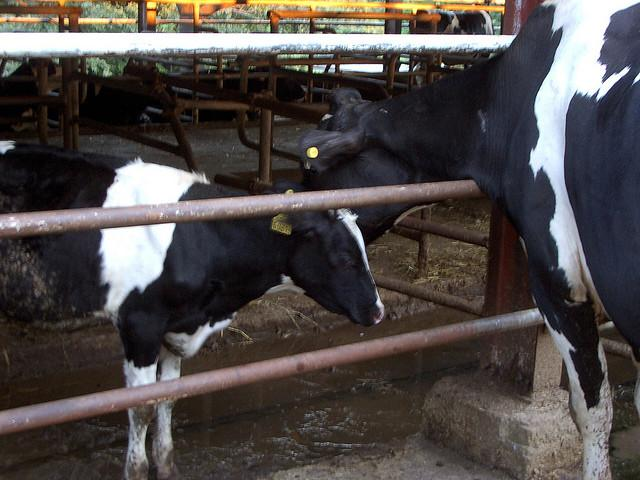Why is the mother cow in a different pen than her calf?

Choices:
A) space restrictions
B) safety
C) feeding
D) cruelty safety 